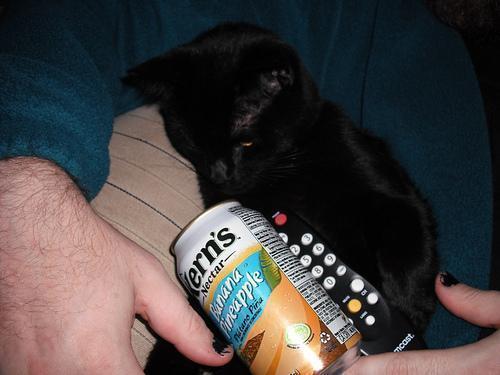Is this affirmation: "The person is on the couch." correct?
Answer yes or no. Yes. 